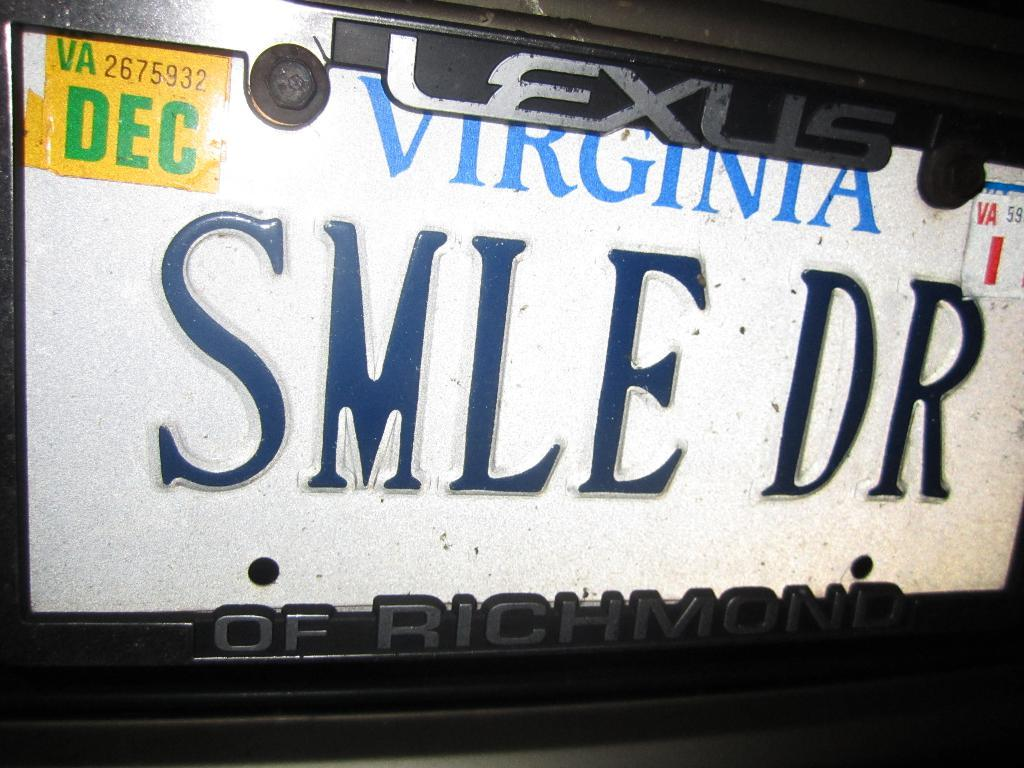<image>
Offer a succinct explanation of the picture presented. A Virginia license plate with inspection tags that run out in December. 